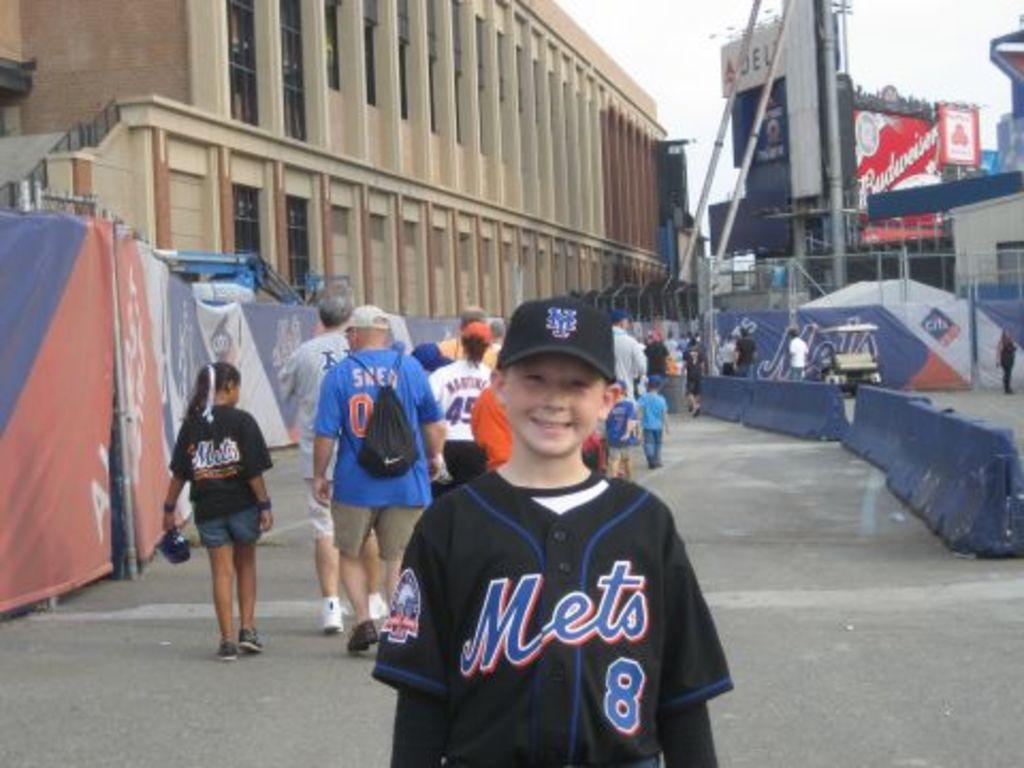What team jersey is the child wearing?
Your response must be concise. Mets. What number is on the jersey?
Offer a very short reply. 8. 